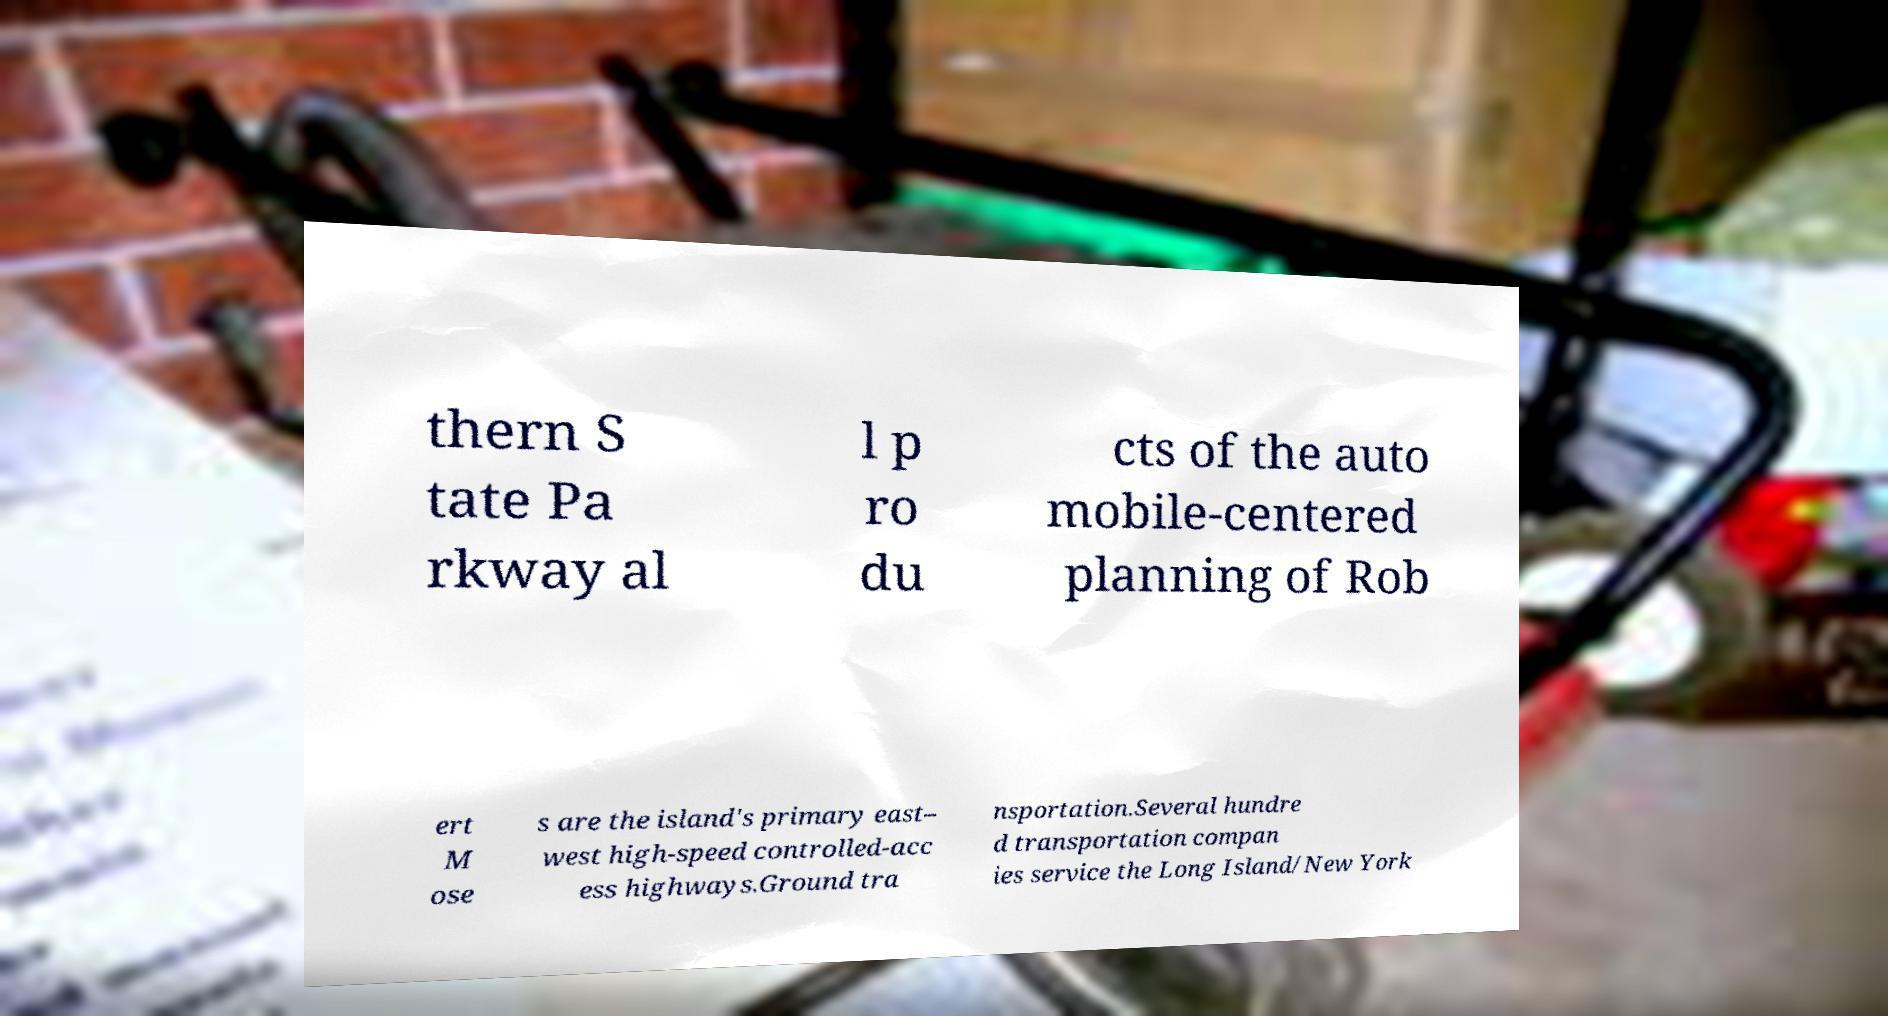There's text embedded in this image that I need extracted. Can you transcribe it verbatim? thern S tate Pa rkway al l p ro du cts of the auto mobile-centered planning of Rob ert M ose s are the island's primary east– west high-speed controlled-acc ess highways.Ground tra nsportation.Several hundre d transportation compan ies service the Long Island/New York 